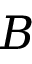Convert formula to latex. <formula><loc_0><loc_0><loc_500><loc_500>B</formula> 